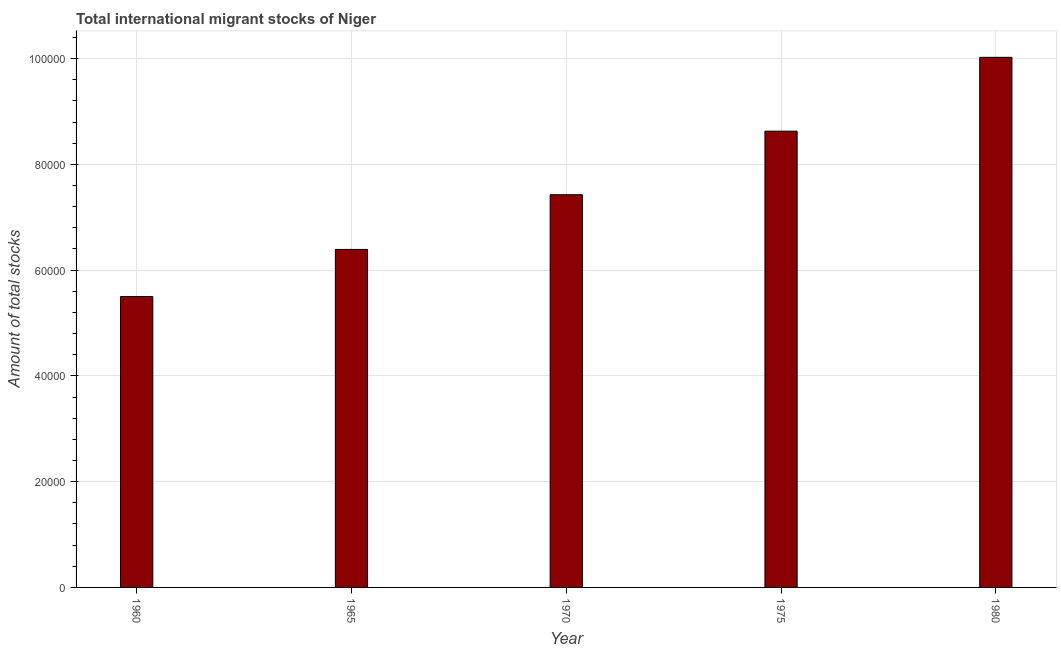What is the title of the graph?
Your response must be concise. Total international migrant stocks of Niger. What is the label or title of the Y-axis?
Make the answer very short. Amount of total stocks. What is the total number of international migrant stock in 1975?
Offer a very short reply. 8.63e+04. Across all years, what is the maximum total number of international migrant stock?
Offer a very short reply. 1.00e+05. Across all years, what is the minimum total number of international migrant stock?
Make the answer very short. 5.50e+04. In which year was the total number of international migrant stock minimum?
Offer a very short reply. 1960. What is the sum of the total number of international migrant stock?
Offer a terse response. 3.80e+05. What is the difference between the total number of international migrant stock in 1965 and 1975?
Keep it short and to the point. -2.24e+04. What is the average total number of international migrant stock per year?
Keep it short and to the point. 7.59e+04. What is the median total number of international migrant stock?
Provide a succinct answer. 7.43e+04. Do a majority of the years between 1980 and 1970 (inclusive) have total number of international migrant stock greater than 40000 ?
Your response must be concise. Yes. What is the ratio of the total number of international migrant stock in 1960 to that in 1975?
Give a very brief answer. 0.64. Is the difference between the total number of international migrant stock in 1970 and 1975 greater than the difference between any two years?
Your answer should be compact. No. What is the difference between the highest and the second highest total number of international migrant stock?
Offer a terse response. 1.40e+04. What is the difference between the highest and the lowest total number of international migrant stock?
Offer a very short reply. 4.52e+04. Are all the bars in the graph horizontal?
Give a very brief answer. No. How many years are there in the graph?
Ensure brevity in your answer.  5. What is the difference between two consecutive major ticks on the Y-axis?
Offer a terse response. 2.00e+04. Are the values on the major ticks of Y-axis written in scientific E-notation?
Give a very brief answer. No. What is the Amount of total stocks of 1960?
Provide a short and direct response. 5.50e+04. What is the Amount of total stocks in 1965?
Provide a short and direct response. 6.39e+04. What is the Amount of total stocks of 1970?
Provide a short and direct response. 7.43e+04. What is the Amount of total stocks of 1975?
Your answer should be compact. 8.63e+04. What is the Amount of total stocks in 1980?
Make the answer very short. 1.00e+05. What is the difference between the Amount of total stocks in 1960 and 1965?
Make the answer very short. -8903. What is the difference between the Amount of total stocks in 1960 and 1970?
Provide a short and direct response. -1.92e+04. What is the difference between the Amount of total stocks in 1960 and 1975?
Give a very brief answer. -3.13e+04. What is the difference between the Amount of total stocks in 1960 and 1980?
Your response must be concise. -4.52e+04. What is the difference between the Amount of total stocks in 1965 and 1970?
Ensure brevity in your answer.  -1.03e+04. What is the difference between the Amount of total stocks in 1965 and 1975?
Offer a terse response. -2.24e+04. What is the difference between the Amount of total stocks in 1965 and 1980?
Your response must be concise. -3.63e+04. What is the difference between the Amount of total stocks in 1970 and 1975?
Provide a short and direct response. -1.20e+04. What is the difference between the Amount of total stocks in 1970 and 1980?
Provide a short and direct response. -2.60e+04. What is the difference between the Amount of total stocks in 1975 and 1980?
Make the answer very short. -1.40e+04. What is the ratio of the Amount of total stocks in 1960 to that in 1965?
Provide a succinct answer. 0.86. What is the ratio of the Amount of total stocks in 1960 to that in 1970?
Ensure brevity in your answer.  0.74. What is the ratio of the Amount of total stocks in 1960 to that in 1975?
Your answer should be compact. 0.64. What is the ratio of the Amount of total stocks in 1960 to that in 1980?
Give a very brief answer. 0.55. What is the ratio of the Amount of total stocks in 1965 to that in 1970?
Give a very brief answer. 0.86. What is the ratio of the Amount of total stocks in 1965 to that in 1975?
Ensure brevity in your answer.  0.74. What is the ratio of the Amount of total stocks in 1965 to that in 1980?
Your response must be concise. 0.64. What is the ratio of the Amount of total stocks in 1970 to that in 1975?
Give a very brief answer. 0.86. What is the ratio of the Amount of total stocks in 1970 to that in 1980?
Your answer should be compact. 0.74. What is the ratio of the Amount of total stocks in 1975 to that in 1980?
Provide a succinct answer. 0.86. 